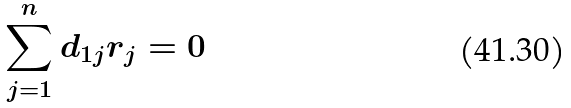<formula> <loc_0><loc_0><loc_500><loc_500>\sum _ { j = 1 } ^ { n } d _ { 1 j } r _ { j } = 0</formula> 